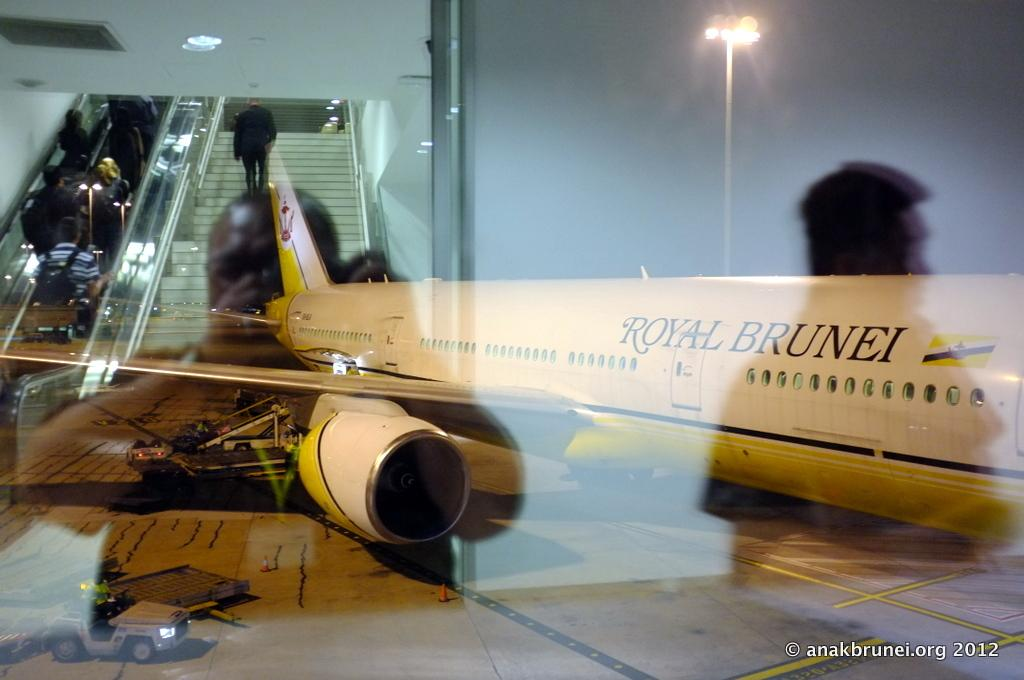<image>
Summarize the visual content of the image. A Royal Brunei plane sits on the runway at night 